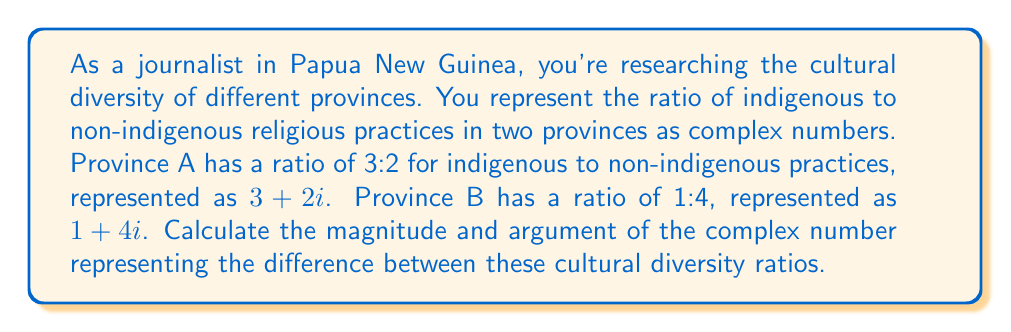Help me with this question. To solve this problem, we need to follow these steps:

1) First, let's find the difference between the two complex numbers:
   $$(3 + 2i) - (1 + 4i) = 2 - 2i$$

2) Now we have a new complex number $z = 2 - 2i$. We need to find its magnitude and argument.

3) The magnitude of a complex number $a + bi$ is given by the formula:
   $$|z| = \sqrt{a^2 + b^2}$$

   In our case:
   $$|z| = \sqrt{2^2 + (-2)^2} = \sqrt{4 + 4} = \sqrt{8} = 2\sqrt{2}$$

4) The argument of a complex number is the angle it makes with the positive real axis. It's calculated using the arctangent function:
   $$\arg(z) = \tan^{-1}(\frac{b}{a})$$

   However, we need to be careful here. Since our real part is positive and imaginary part is negative, we're in the fourth quadrant. We need to add $2\pi$ to the result of arctangent.

   $$\arg(z) = \tan^{-1}(\frac{-2}{2}) + 2\pi = -\frac{\pi}{4} + 2\pi = \frac{7\pi}{4}$$

5) Therefore, the magnitude is $2\sqrt{2}$ and the argument is $\frac{7\pi}{4}$ radians.
Answer: Magnitude: $2\sqrt{2}$
Argument: $\frac{7\pi}{4}$ radians 